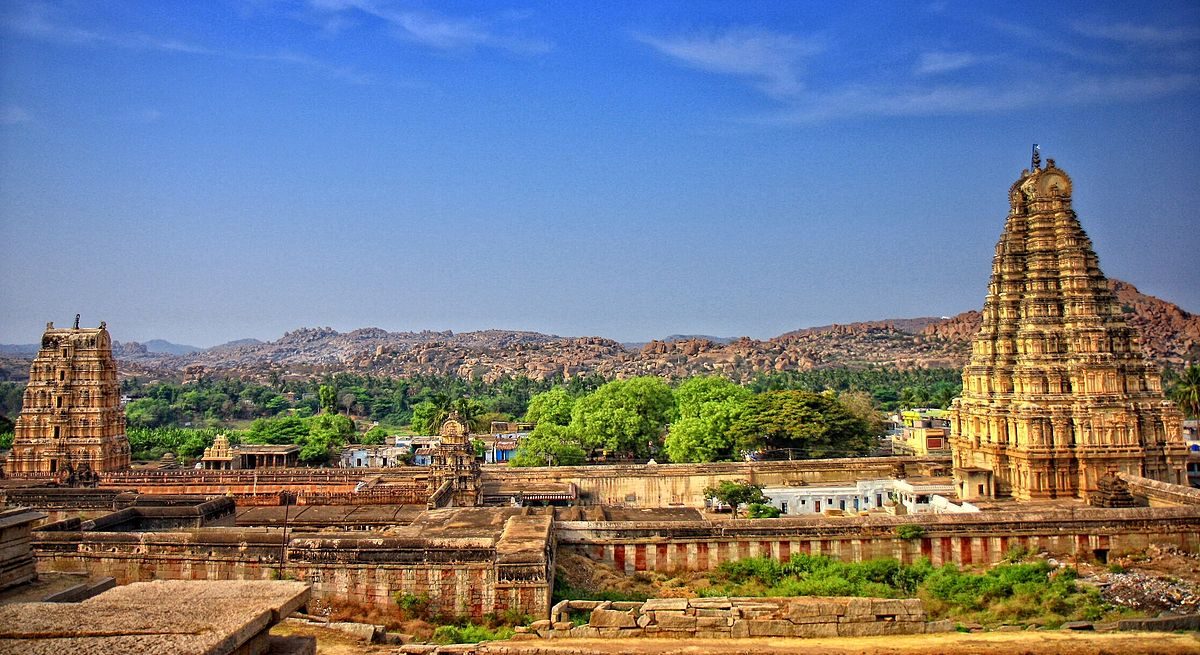Write a detailed description of the given image. The image captures the grandeur of the Virupaksha Temple, a revered Hindu temple nestled in the historic ruins of Hampi, India. The temple, dedicated to Lord Shiva, stands as one of the oldest functioning temples in the country. The photograph is taken from a high vantage point, offering a panoramic view of the temple complex and the surrounding landscape.

The temple's tall gopurams, or temple towers, dominate the scene. These towers, adorned with intricate carvings, rise majestically against the backdrop of a clear blue sky. The warm hues of the temple structures contrast beautifully with the cool tones of the sky, creating a visually striking image.

The perspective of the image allows for a comprehensive view of the temple complex, revealing the scale and architectural brilliance of this landmark. The surrounding landscape, dotted with vegetation, adds a touch of nature to the man-made marvel, enhancing the overall composition of the photograph. The image is a testament to the rich cultural heritage and architectural prowess of ancient India. 